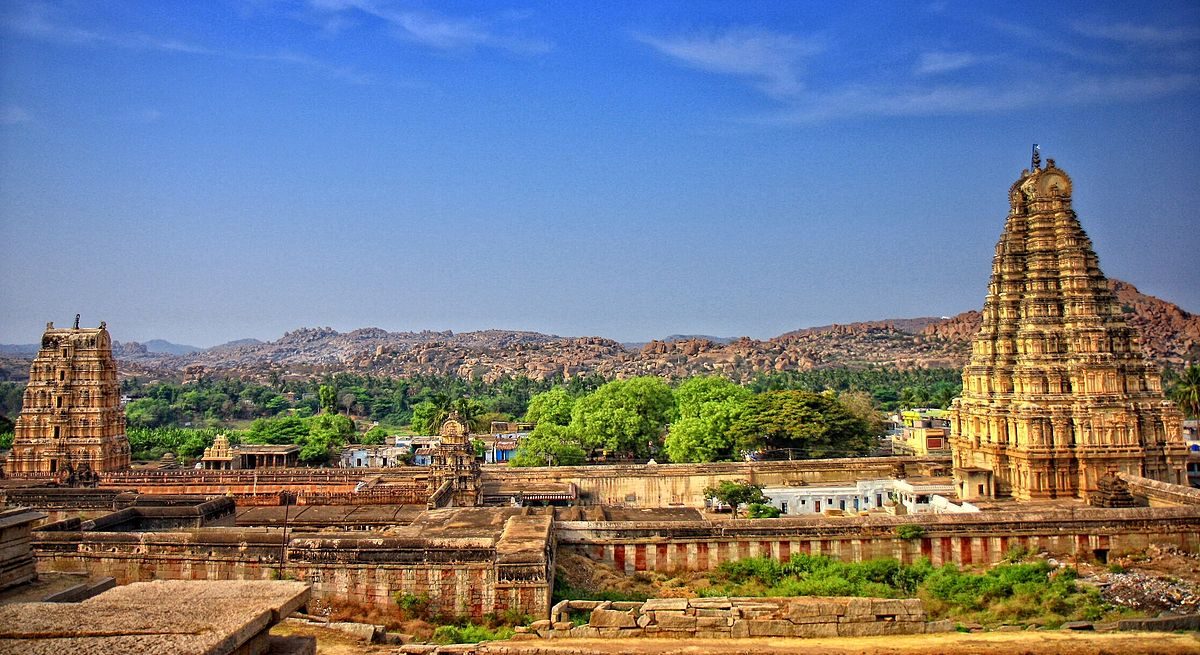Write a detailed description of the given image. The image captures the grandeur of the Virupaksha Temple, a revered Hindu temple nestled in the historic ruins of Hampi, India. The temple, dedicated to Lord Shiva, stands as one of the oldest functioning temples in the country. The photograph is taken from a high vantage point, offering a panoramic view of the temple complex and the surrounding landscape.

The temple's tall gopurams, or temple towers, dominate the scene. These towers, adorned with intricate carvings, rise majestically against the backdrop of a clear blue sky. The warm hues of the temple structures contrast beautifully with the cool tones of the sky, creating a visually striking image.

The perspective of the image allows for a comprehensive view of the temple complex, revealing the scale and architectural brilliance of this landmark. The surrounding landscape, dotted with vegetation, adds a touch of nature to the man-made marvel, enhancing the overall composition of the photograph. The image is a testament to the rich cultural heritage and architectural prowess of ancient India. 